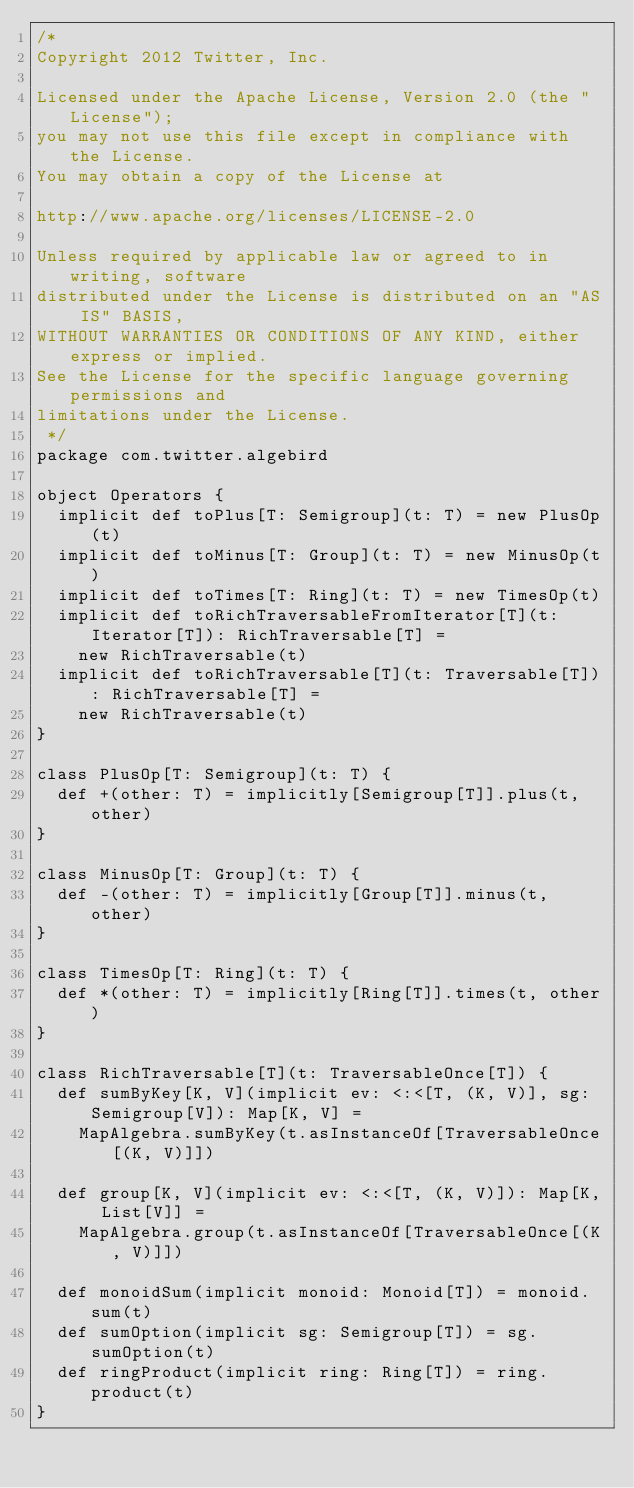Convert code to text. <code><loc_0><loc_0><loc_500><loc_500><_Scala_>/*
Copyright 2012 Twitter, Inc.

Licensed under the Apache License, Version 2.0 (the "License");
you may not use this file except in compliance with the License.
You may obtain a copy of the License at

http://www.apache.org/licenses/LICENSE-2.0

Unless required by applicable law or agreed to in writing, software
distributed under the License is distributed on an "AS IS" BASIS,
WITHOUT WARRANTIES OR CONDITIONS OF ANY KIND, either express or implied.
See the License for the specific language governing permissions and
limitations under the License.
 */
package com.twitter.algebird

object Operators {
  implicit def toPlus[T: Semigroup](t: T) = new PlusOp(t)
  implicit def toMinus[T: Group](t: T) = new MinusOp(t)
  implicit def toTimes[T: Ring](t: T) = new TimesOp(t)
  implicit def toRichTraversableFromIterator[T](t: Iterator[T]): RichTraversable[T] =
    new RichTraversable(t)
  implicit def toRichTraversable[T](t: Traversable[T]): RichTraversable[T] =
    new RichTraversable(t)
}

class PlusOp[T: Semigroup](t: T) {
  def +(other: T) = implicitly[Semigroup[T]].plus(t, other)
}

class MinusOp[T: Group](t: T) {
  def -(other: T) = implicitly[Group[T]].minus(t, other)
}

class TimesOp[T: Ring](t: T) {
  def *(other: T) = implicitly[Ring[T]].times(t, other)
}

class RichTraversable[T](t: TraversableOnce[T]) {
  def sumByKey[K, V](implicit ev: <:<[T, (K, V)], sg: Semigroup[V]): Map[K, V] =
    MapAlgebra.sumByKey(t.asInstanceOf[TraversableOnce[(K, V)]])

  def group[K, V](implicit ev: <:<[T, (K, V)]): Map[K, List[V]] =
    MapAlgebra.group(t.asInstanceOf[TraversableOnce[(K, V)]])

  def monoidSum(implicit monoid: Monoid[T]) = monoid.sum(t)
  def sumOption(implicit sg: Semigroup[T]) = sg.sumOption(t)
  def ringProduct(implicit ring: Ring[T]) = ring.product(t)
}
</code> 